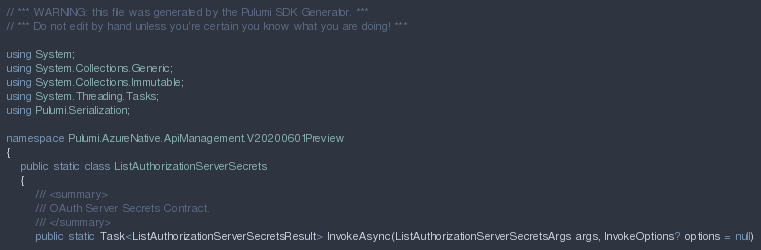Convert code to text. <code><loc_0><loc_0><loc_500><loc_500><_C#_>// *** WARNING: this file was generated by the Pulumi SDK Generator. ***
// *** Do not edit by hand unless you're certain you know what you are doing! ***

using System;
using System.Collections.Generic;
using System.Collections.Immutable;
using System.Threading.Tasks;
using Pulumi.Serialization;

namespace Pulumi.AzureNative.ApiManagement.V20200601Preview
{
    public static class ListAuthorizationServerSecrets
    {
        /// <summary>
        /// OAuth Server Secrets Contract.
        /// </summary>
        public static Task<ListAuthorizationServerSecretsResult> InvokeAsync(ListAuthorizationServerSecretsArgs args, InvokeOptions? options = null)</code> 